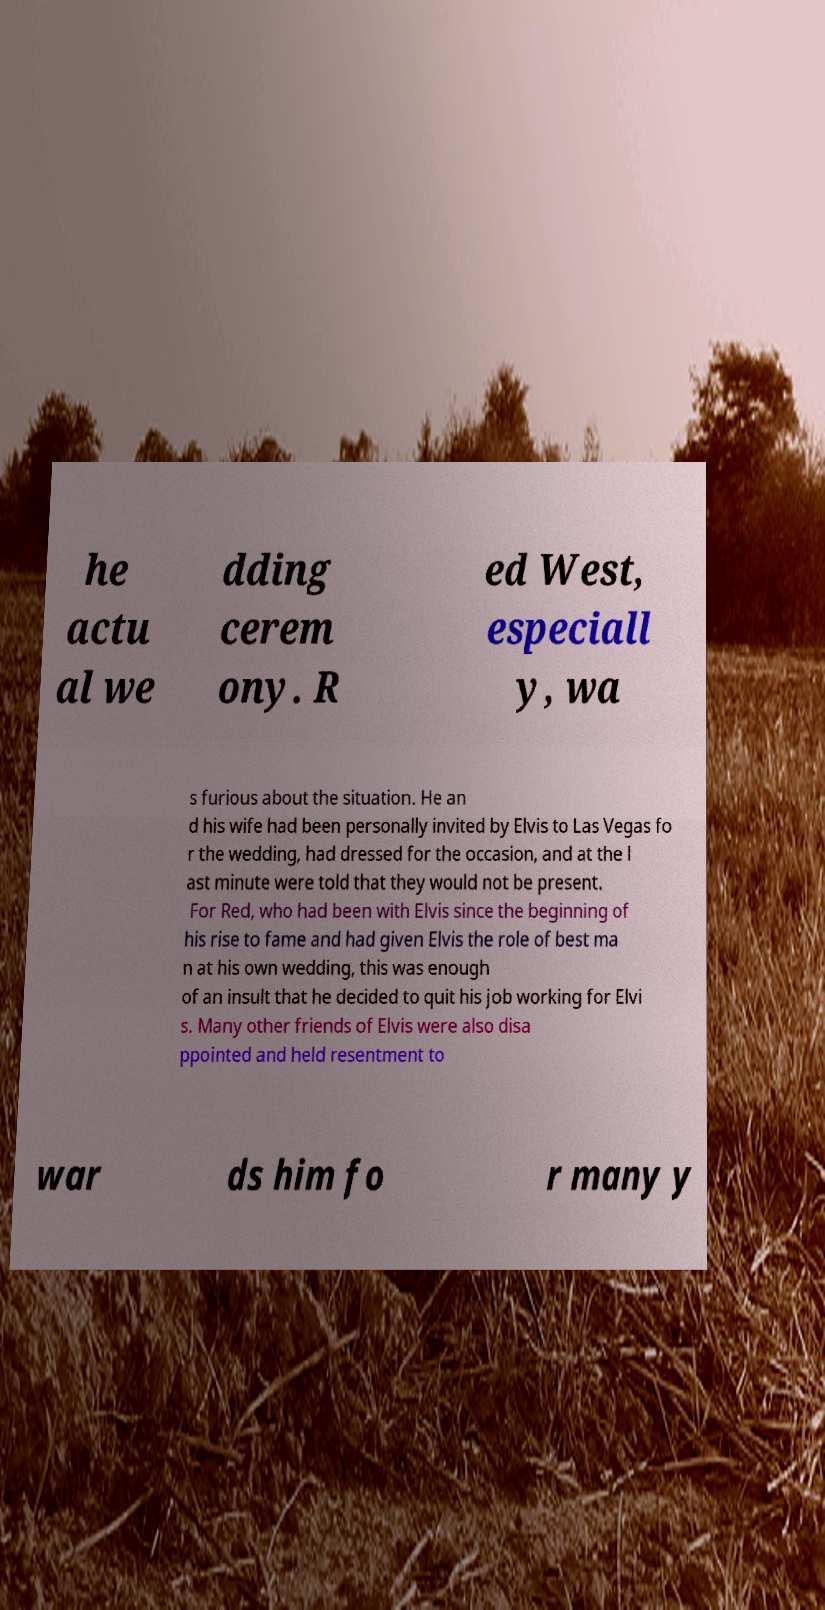For documentation purposes, I need the text within this image transcribed. Could you provide that? he actu al we dding cerem ony. R ed West, especiall y, wa s furious about the situation. He an d his wife had been personally invited by Elvis to Las Vegas fo r the wedding, had dressed for the occasion, and at the l ast minute were told that they would not be present. For Red, who had been with Elvis since the beginning of his rise to fame and had given Elvis the role of best ma n at his own wedding, this was enough of an insult that he decided to quit his job working for Elvi s. Many other friends of Elvis were also disa ppointed and held resentment to war ds him fo r many y 